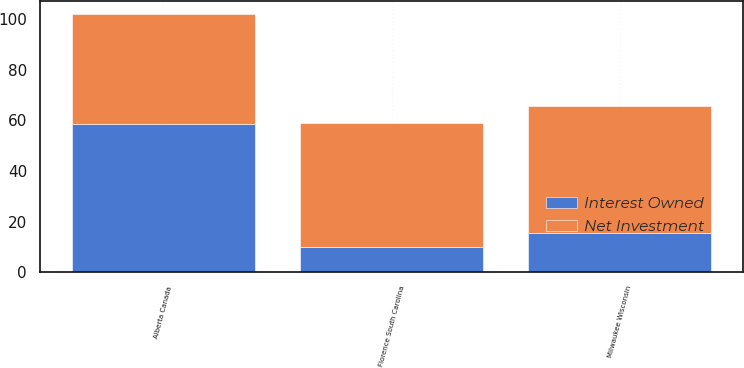<chart> <loc_0><loc_0><loc_500><loc_500><stacked_bar_chart><ecel><fcel>Milwaukee Wisconsin<fcel>Alberta Canada<fcel>Florence South Carolina<nl><fcel>Interest Owned<fcel>15.5<fcel>58.5<fcel>10<nl><fcel>Net Investment<fcel>50<fcel>43.37<fcel>49<nl></chart> 